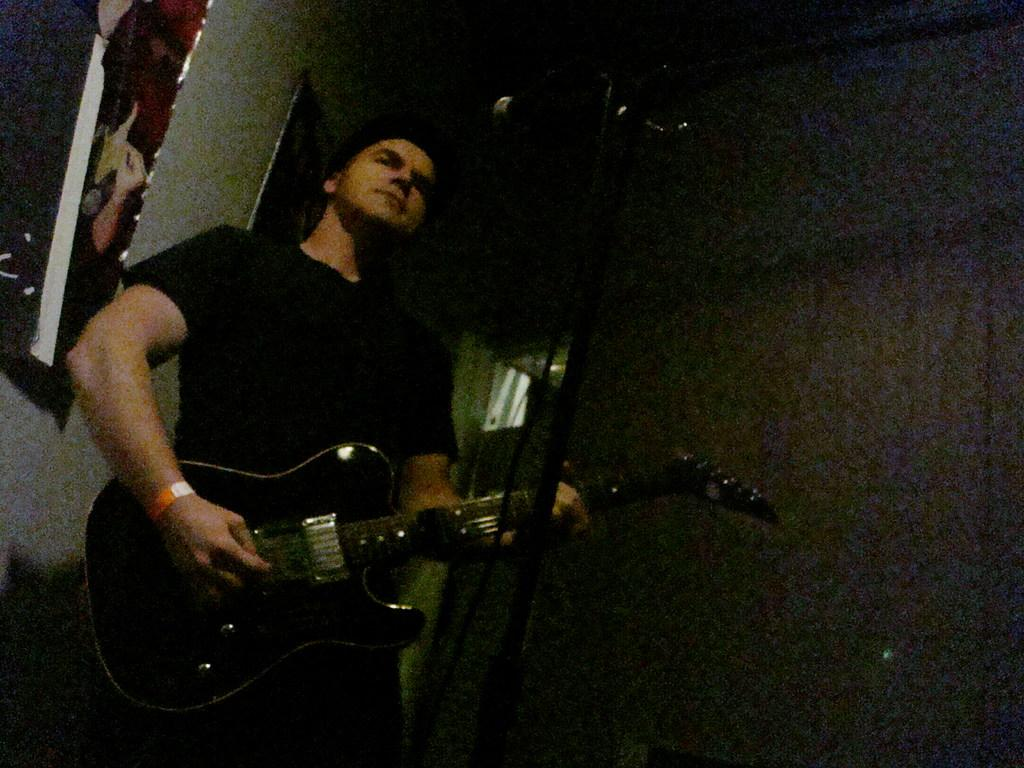What is the man in the image doing? The man is playing a guitar. What is the man wearing in the image? The man is wearing a black t-shirt. What can be seen in the background of the image? There is a wall in the image. What type of gate can be seen in the image? There is no gate present in the image. What kind of net is being used by the man in the image? The man is not using a net in the image; he is playing a guitar. 